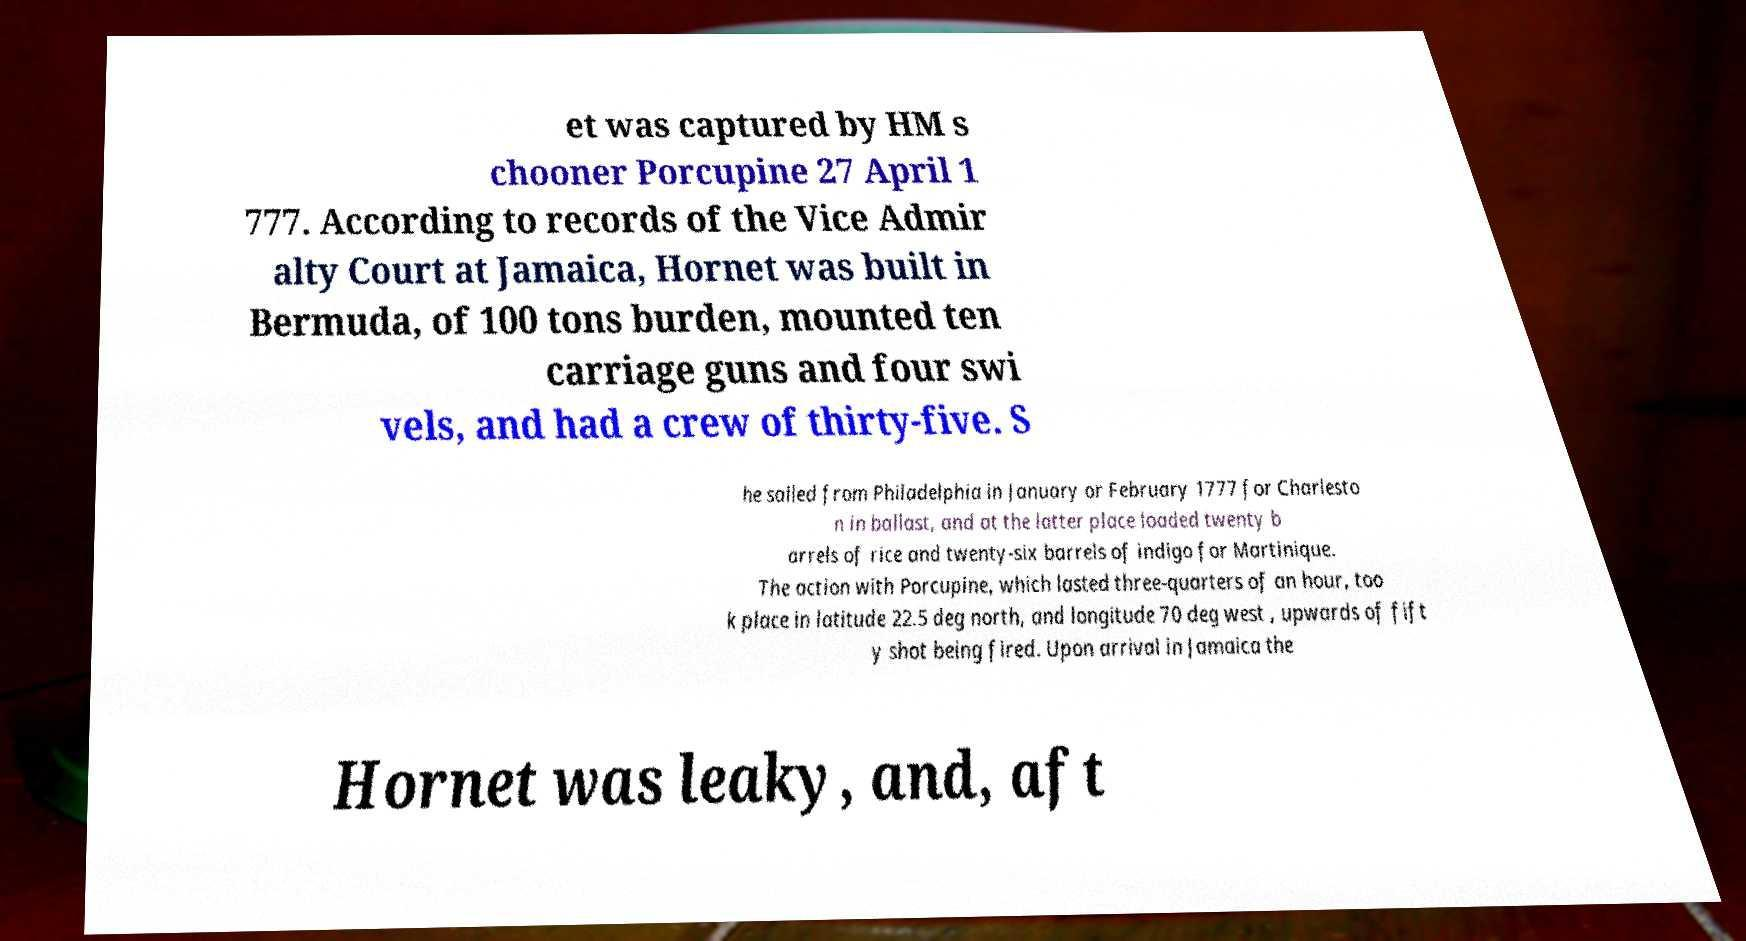Can you read and provide the text displayed in the image?This photo seems to have some interesting text. Can you extract and type it out for me? et was captured by HM s chooner Porcupine 27 April 1 777. According to records of the Vice Admir alty Court at Jamaica, Hornet was built in Bermuda, of 100 tons burden, mounted ten carriage guns and four swi vels, and had a crew of thirty-five. S he sailed from Philadelphia in January or February 1777 for Charlesto n in ballast, and at the latter place loaded twenty b arrels of rice and twenty-six barrels of indigo for Martinique. The action with Porcupine, which lasted three-quarters of an hour, too k place in latitude 22.5 deg north, and longitude 70 deg west , upwards of fift y shot being fired. Upon arrival in Jamaica the Hornet was leaky, and, aft 